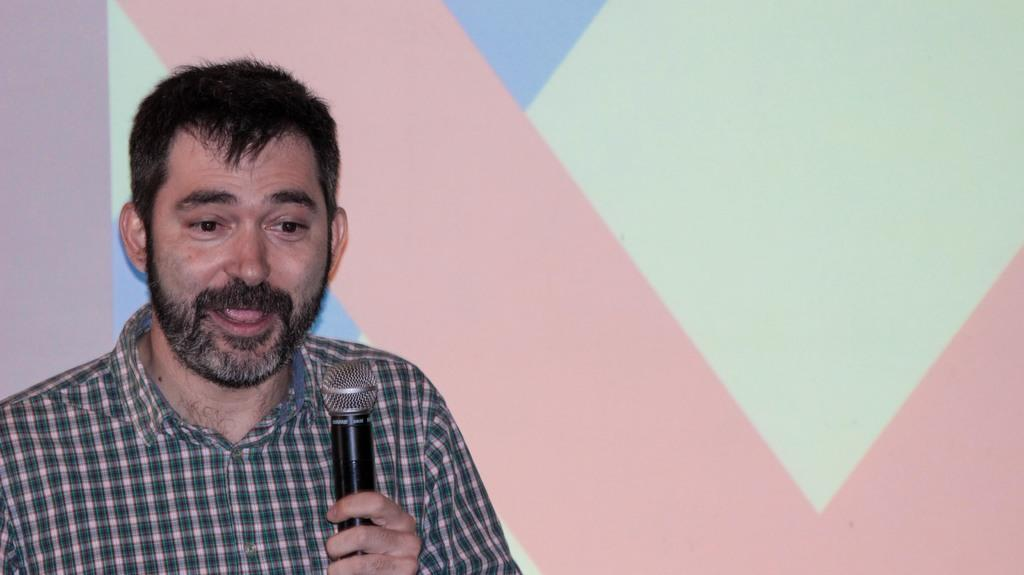What is the main subject of the image? The main subject of the image is a man. What is the man doing in the image? The man is standing and speaking in the image. What object is present in the image that might be related to the man's activity? There is a microphone in the image. What type of fruit is being processed by the machine in the image? There is no machine or fruit present in the image; it features a man standing and speaking with a microphone. 